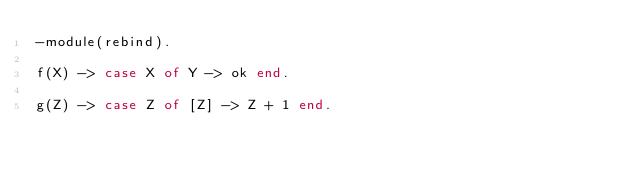Convert code to text. <code><loc_0><loc_0><loc_500><loc_500><_Erlang_>-module(rebind).

f(X) -> case X of Y -> ok end.

g(Z) -> case Z of [Z] -> Z + 1 end.
</code> 